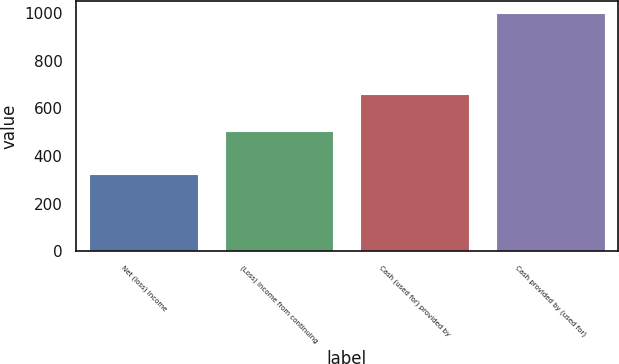<chart> <loc_0><loc_0><loc_500><loc_500><bar_chart><fcel>Net (loss) income<fcel>(Loss) income from continuing<fcel>Cash (used for) provided by<fcel>Cash provided by (used for)<nl><fcel>326<fcel>504<fcel>662<fcel>1001<nl></chart> 